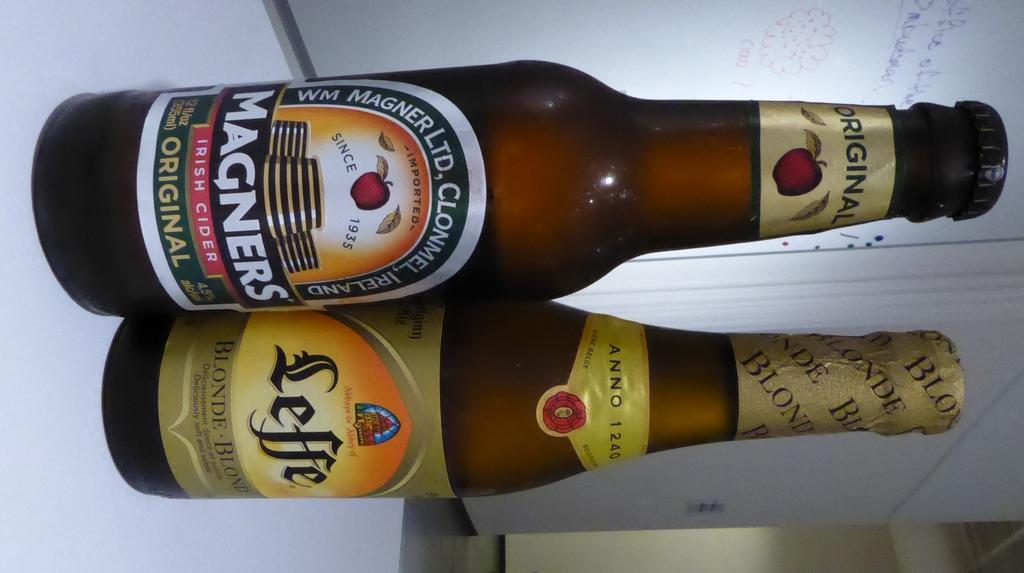<image>
Summarize the visual content of the image. a bottle of magners original next to a bottle of leffe 